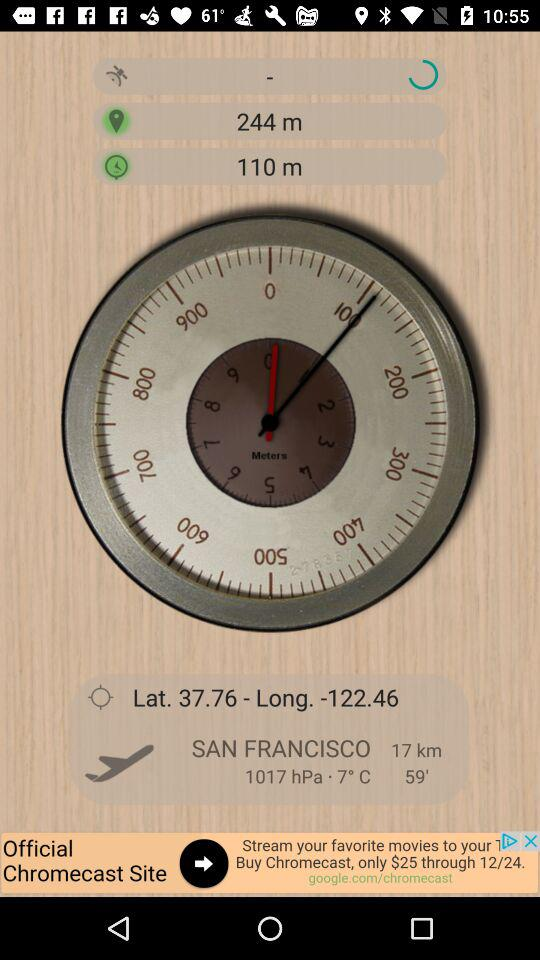What is the distance of the city? the distance of the city is 17 km. 